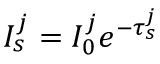<formula> <loc_0><loc_0><loc_500><loc_500>I _ { s } ^ { j } = I _ { 0 } ^ { j } e ^ { - { \tau _ { s } ^ { j } } }</formula> 